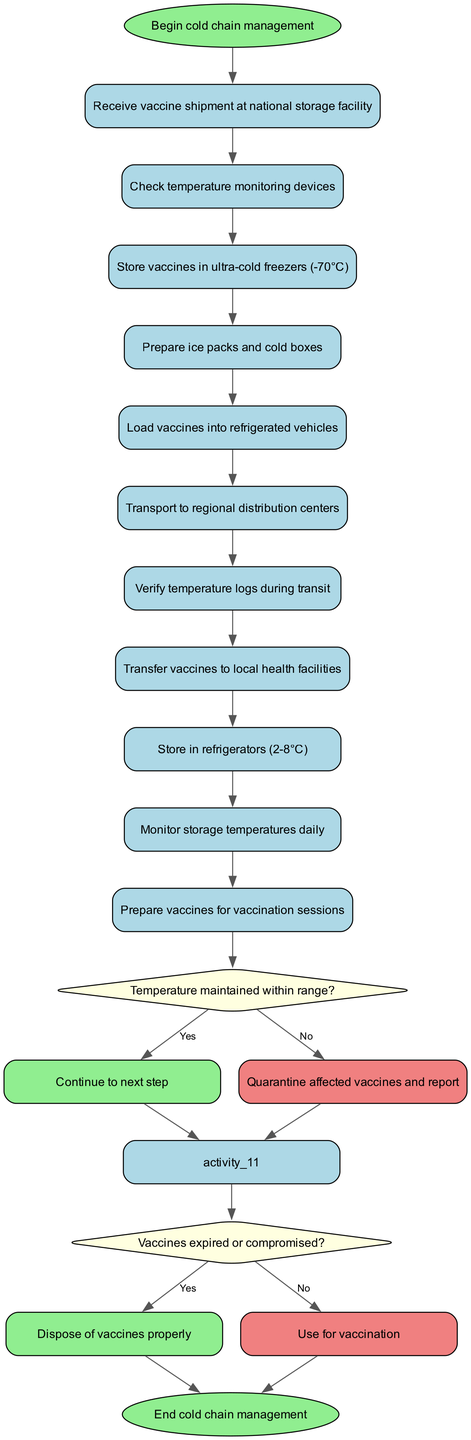What is the first activity in the cold chain management process? The first activity listed in the diagram is "Receive vaccine shipment at national storage facility". This is the initial step that follows the start node.
Answer: Receive vaccine shipment at national storage facility How many decision points are present in the diagram? The diagram includes two decision points: one regarding temperature maintenance and another about whether the vaccines are expired or compromised. Each decision point is represented as a diamond-shaped node.
Answer: 2 What action is taken if the temperature is not maintained within range? According to the diagram, if the temperature is not maintained, the affected vaccines should be quarantined and reported. This is the specific action to be followed based on the decision node's "No" path.
Answer: Quarantine affected vaccines and report Which activity follows the transport to regional distribution centers? The next activity after "Transport to regional distribution centers" is "Verify temperature logs during transit". This can be understood by following the flow of activities from one to the next in the diagram.
Answer: Verify temperature logs during transit What happens if vaccines are expired or compromised? The diagram states that if the vaccines are expired or compromised, they should be disposed of properly. This is the outcome of the decision point leading from the "No" path of the second decision node.
Answer: Dispose of vaccines properly What is the last activity before ending the cold chain management process? Prior to reaching the end node, the last activity is "Prepare vaccines for vaccination sessions". This is the activity leading directly into the end of the process.
Answer: Prepare vaccines for vaccination sessions 